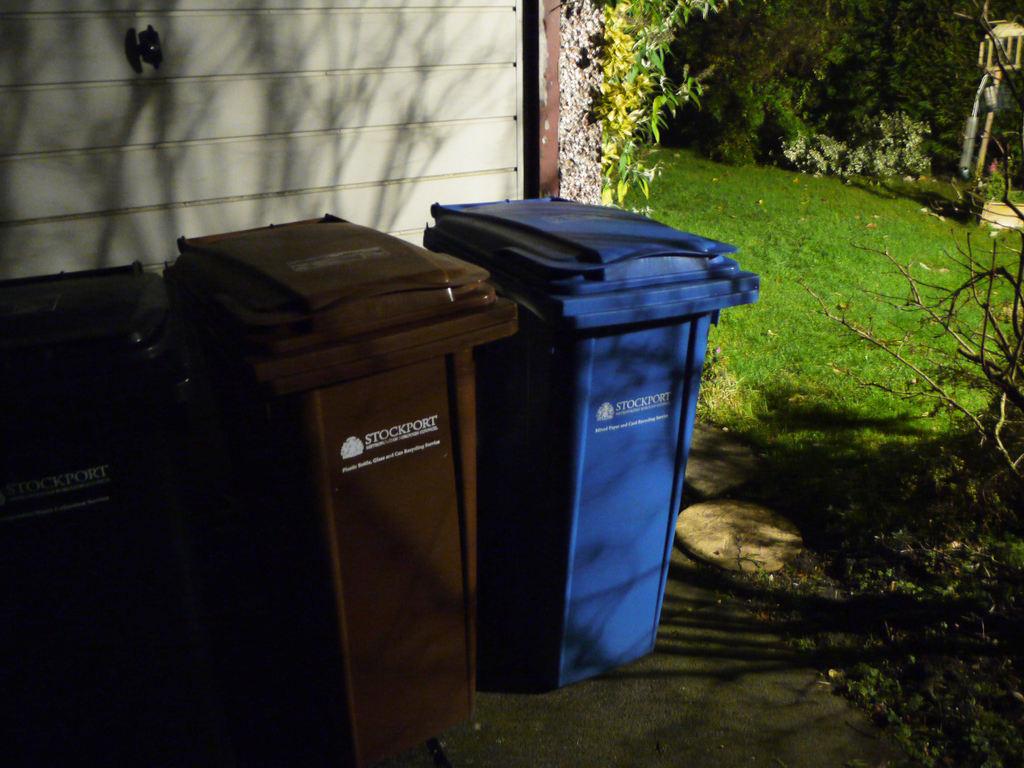How many different colors are the dustbins?
Ensure brevity in your answer.  Answering does not require reading text in the image. What trash company takes away the trash from this house?
Make the answer very short. Stockport. 